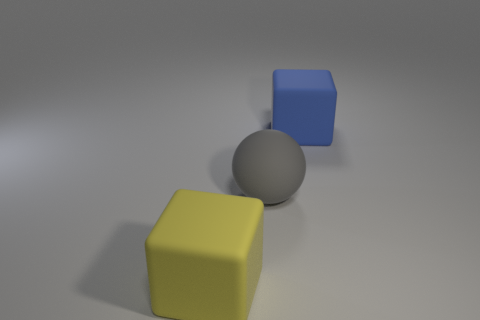There is another rubber thing that is the same shape as the yellow matte object; what is its size?
Offer a very short reply. Large. Are there any other things that are the same size as the blue cube?
Your answer should be compact. Yes. What number of things are rubber cubes that are to the left of the gray thing or rubber blocks to the left of the blue matte object?
Your answer should be compact. 1. Is the matte sphere the same size as the yellow matte thing?
Give a very brief answer. Yes. Is the number of big blocks greater than the number of blue matte cubes?
Your answer should be very brief. Yes. What number of other objects are there of the same color as the large ball?
Give a very brief answer. 0. How many things are either small green metal cubes or cubes?
Provide a succinct answer. 2. Is the shape of the large yellow thing left of the big blue thing the same as  the blue matte thing?
Make the answer very short. Yes. The big cube on the right side of the large matte thing that is on the left side of the big ball is what color?
Make the answer very short. Blue. Are there fewer blue matte things than matte objects?
Your answer should be compact. Yes. 